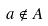Convert formula to latex. <formula><loc_0><loc_0><loc_500><loc_500>a \notin A</formula> 